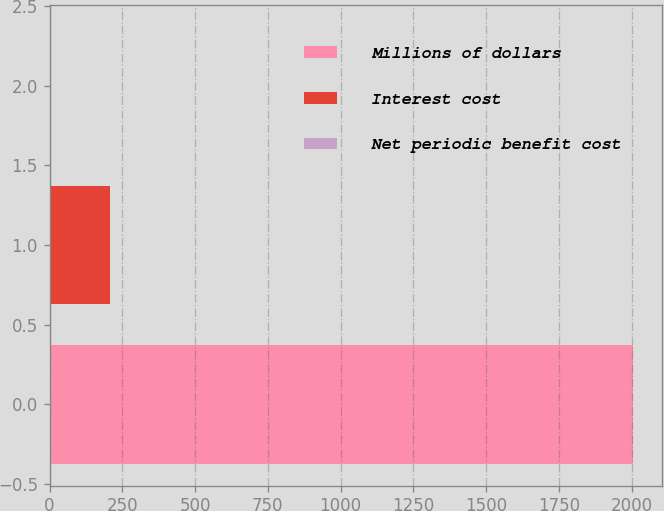Convert chart to OTSL. <chart><loc_0><loc_0><loc_500><loc_500><bar_chart><fcel>Millions of dollars<fcel>Interest cost<fcel>Net periodic benefit cost<nl><fcel>2006<fcel>206<fcel>6<nl></chart> 